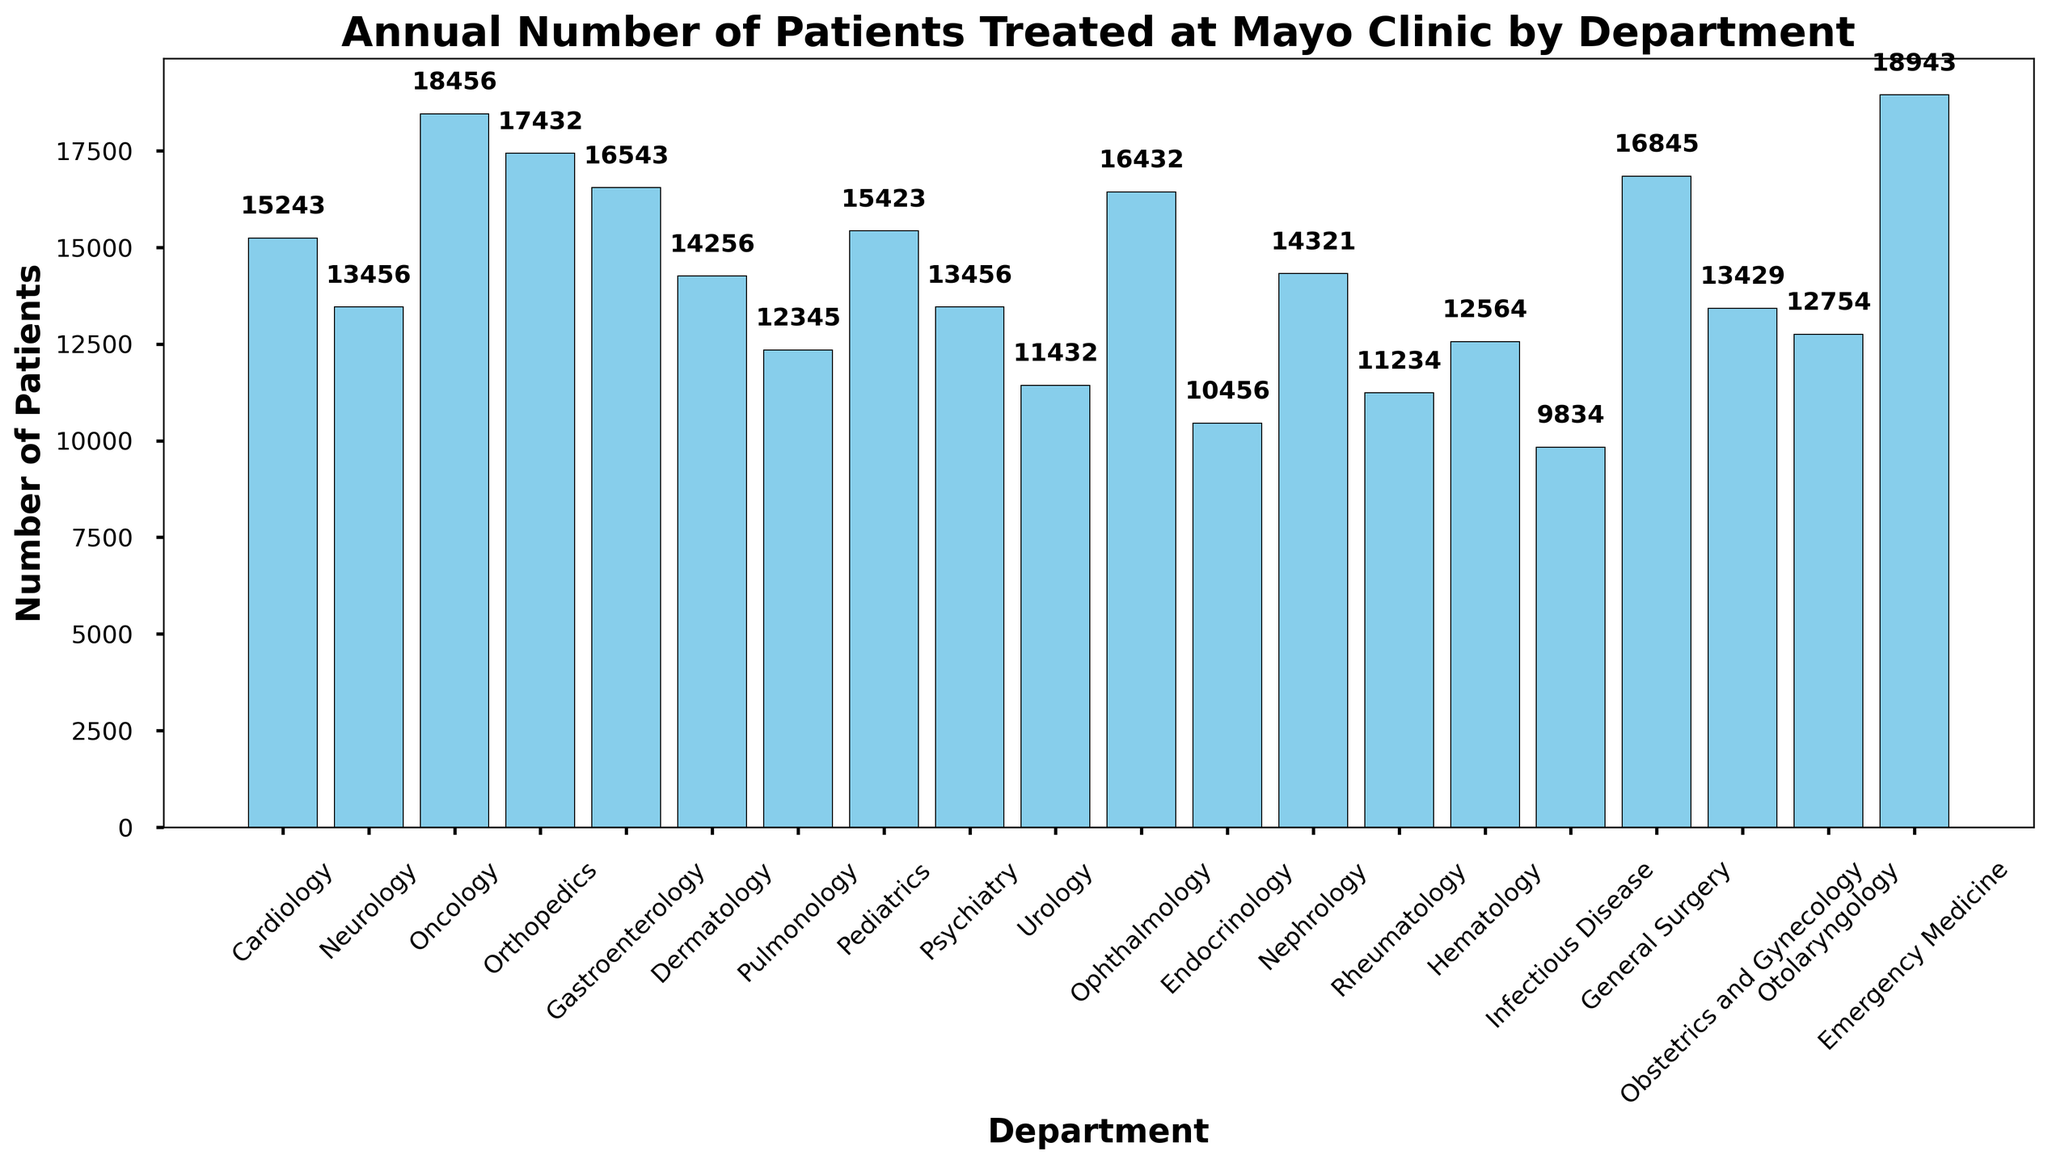Which department treated the highest number of patients annually? Look for the tallest bar in the histogram. The Emergency Medicine bar is the tallest.
Answer: Emergency Medicine Which department treated the lowest number of patients annually? Look for the shortest bar in the histogram. The Infectious Disease bar is the shortest.
Answer: Infectious Disease What is the difference in the number of patients treated between Emergency Medicine and Infectious Disease departments? Identify the heights of the bars for Emergency Medicine and Infectious Disease, then subtract the smaller value from the larger one. Emergency Medicine treated 18,943 patients and Infectious Disease treated 9,834. The difference is 18,943 - 9,834 = 9,109.
Answer: 9,109 How many departments treated more than 15,000 patients annually? Count the bars that exceed the 15,000 mark on the y-axis. Those departments are Cardiology, Oncology, Orthopedics, Gastroenterology, Pediatrics, and Emergency Medicine.
Answer: 6 What’s the average number of patients treated annually across all departments? Add the number of patients treated in each department and divide by the total number of departments (20). The sum is 289,019. Dividing by 20 gives an average of 14,451.
Answer: 14,451 Which departments treated a similar number of patients annually? Look for bars that are approximately the same height. Neurology and Psychiatry both treated 13,456 patients, and Cardiology and Pediatrics treated nearly similar numbers (15,243 and 15,423 respectively).
Answer: Neurology and Psychiatry; Cardiology and Pediatrics What’s the combined number of patients treated by Cardiology, Oncology, and Orthopedics? Add the number of patients treated by Cardiology (15,243), Oncology (18,456), and Orthopedics (17,432). The combined total is 15,243 + 18,456 + 17,432 = 51,131.
Answer: 51,131 How does the number of patients treated in Dermatology compare to that in Nephrology? Identify the heights of the bars for Dermatology and Nephrology. Dermatology treated 14,256 patients and Nephrology treated 14,321 patients. Dermatology treated slightly fewer patients than Nephrology.
Answer: Fewer Are there more departments that treated between 10,000 and 15,000 patients or more than 15,000 patients? Count the number of departments in each range. Departments with 10,000 to 15,000 patients are 8 (Neurology, Dermatology, Pulmonology, Psychiatry, Urology, Endocrinology, Nephrology, Rheumatology), and departments with more than 15,000 are 6 (Cardiology, Oncology, Orthopedics, Gastroenterology, Pediatrics, Emergency Medicine).
Answer: More departments treated between 10,000 and 15,000 